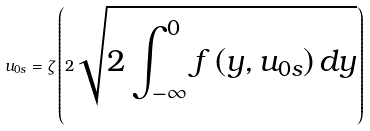<formula> <loc_0><loc_0><loc_500><loc_500>u _ { 0 s } = \zeta \left ( 2 \sqrt { 2 \int _ { - \infty } ^ { 0 } f \left ( y , u _ { 0 s } \right ) d y } \right )</formula> 